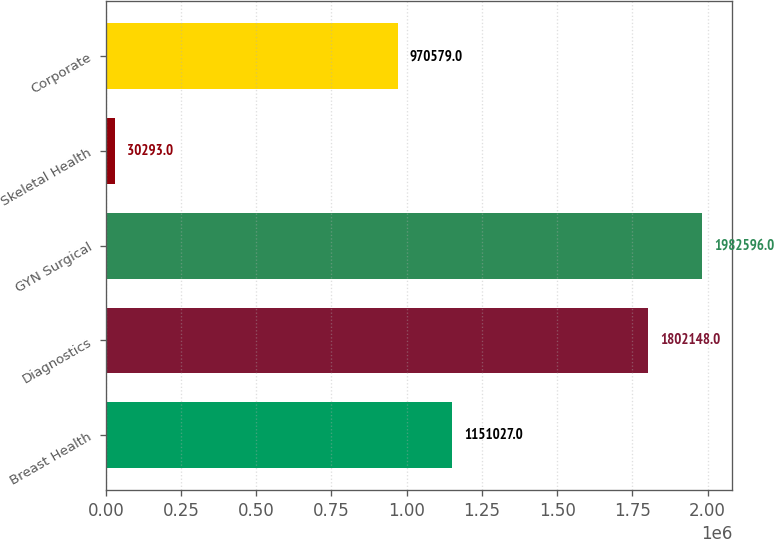Convert chart. <chart><loc_0><loc_0><loc_500><loc_500><bar_chart><fcel>Breast Health<fcel>Diagnostics<fcel>GYN Surgical<fcel>Skeletal Health<fcel>Corporate<nl><fcel>1.15103e+06<fcel>1.80215e+06<fcel>1.9826e+06<fcel>30293<fcel>970579<nl></chart> 